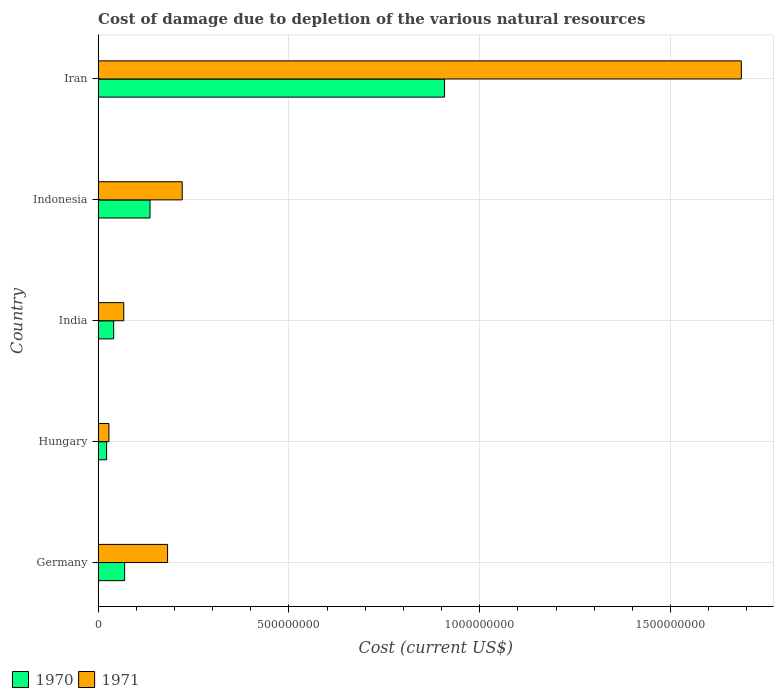Are the number of bars per tick equal to the number of legend labels?
Provide a short and direct response. Yes. Are the number of bars on each tick of the Y-axis equal?
Your answer should be very brief. Yes. How many bars are there on the 3rd tick from the bottom?
Provide a succinct answer. 2. What is the cost of damage caused due to the depletion of various natural resources in 1970 in Hungary?
Ensure brevity in your answer.  2.22e+07. Across all countries, what is the maximum cost of damage caused due to the depletion of various natural resources in 1971?
Ensure brevity in your answer.  1.69e+09. Across all countries, what is the minimum cost of damage caused due to the depletion of various natural resources in 1970?
Keep it short and to the point. 2.22e+07. In which country was the cost of damage caused due to the depletion of various natural resources in 1970 maximum?
Provide a short and direct response. Iran. In which country was the cost of damage caused due to the depletion of various natural resources in 1970 minimum?
Give a very brief answer. Hungary. What is the total cost of damage caused due to the depletion of various natural resources in 1971 in the graph?
Offer a terse response. 2.18e+09. What is the difference between the cost of damage caused due to the depletion of various natural resources in 1971 in Germany and that in Iran?
Your response must be concise. -1.50e+09. What is the difference between the cost of damage caused due to the depletion of various natural resources in 1970 in Germany and the cost of damage caused due to the depletion of various natural resources in 1971 in Hungary?
Offer a terse response. 4.12e+07. What is the average cost of damage caused due to the depletion of various natural resources in 1970 per country?
Make the answer very short. 2.35e+08. What is the difference between the cost of damage caused due to the depletion of various natural resources in 1970 and cost of damage caused due to the depletion of various natural resources in 1971 in Germany?
Offer a very short reply. -1.13e+08. In how many countries, is the cost of damage caused due to the depletion of various natural resources in 1971 greater than 1400000000 US$?
Keep it short and to the point. 1. What is the ratio of the cost of damage caused due to the depletion of various natural resources in 1970 in Germany to that in Indonesia?
Provide a short and direct response. 0.51. What is the difference between the highest and the second highest cost of damage caused due to the depletion of various natural resources in 1970?
Make the answer very short. 7.72e+08. What is the difference between the highest and the lowest cost of damage caused due to the depletion of various natural resources in 1971?
Your answer should be very brief. 1.66e+09. Is the sum of the cost of damage caused due to the depletion of various natural resources in 1970 in Germany and Hungary greater than the maximum cost of damage caused due to the depletion of various natural resources in 1971 across all countries?
Offer a very short reply. No. How many bars are there?
Offer a terse response. 10. Does the graph contain any zero values?
Make the answer very short. No. Where does the legend appear in the graph?
Ensure brevity in your answer.  Bottom left. How many legend labels are there?
Give a very brief answer. 2. What is the title of the graph?
Your answer should be very brief. Cost of damage due to depletion of the various natural resources. What is the label or title of the X-axis?
Your answer should be very brief. Cost (current US$). What is the label or title of the Y-axis?
Keep it short and to the point. Country. What is the Cost (current US$) of 1970 in Germany?
Provide a succinct answer. 6.95e+07. What is the Cost (current US$) in 1971 in Germany?
Keep it short and to the point. 1.82e+08. What is the Cost (current US$) in 1970 in Hungary?
Ensure brevity in your answer.  2.22e+07. What is the Cost (current US$) of 1971 in Hungary?
Provide a short and direct response. 2.83e+07. What is the Cost (current US$) in 1970 in India?
Make the answer very short. 4.07e+07. What is the Cost (current US$) of 1971 in India?
Provide a short and direct response. 6.72e+07. What is the Cost (current US$) in 1970 in Indonesia?
Give a very brief answer. 1.36e+08. What is the Cost (current US$) in 1971 in Indonesia?
Offer a terse response. 2.20e+08. What is the Cost (current US$) in 1970 in Iran?
Provide a short and direct response. 9.08e+08. What is the Cost (current US$) in 1971 in Iran?
Offer a very short reply. 1.69e+09. Across all countries, what is the maximum Cost (current US$) in 1970?
Your answer should be compact. 9.08e+08. Across all countries, what is the maximum Cost (current US$) in 1971?
Your answer should be compact. 1.69e+09. Across all countries, what is the minimum Cost (current US$) in 1970?
Your answer should be compact. 2.22e+07. Across all countries, what is the minimum Cost (current US$) of 1971?
Your response must be concise. 2.83e+07. What is the total Cost (current US$) in 1970 in the graph?
Your answer should be compact. 1.18e+09. What is the total Cost (current US$) of 1971 in the graph?
Your answer should be very brief. 2.18e+09. What is the difference between the Cost (current US$) of 1970 in Germany and that in Hungary?
Offer a terse response. 4.72e+07. What is the difference between the Cost (current US$) of 1971 in Germany and that in Hungary?
Your response must be concise. 1.54e+08. What is the difference between the Cost (current US$) in 1970 in Germany and that in India?
Ensure brevity in your answer.  2.88e+07. What is the difference between the Cost (current US$) in 1971 in Germany and that in India?
Provide a short and direct response. 1.15e+08. What is the difference between the Cost (current US$) in 1970 in Germany and that in Indonesia?
Your response must be concise. -6.65e+07. What is the difference between the Cost (current US$) of 1971 in Germany and that in Indonesia?
Ensure brevity in your answer.  -3.83e+07. What is the difference between the Cost (current US$) of 1970 in Germany and that in Iran?
Offer a terse response. -8.38e+08. What is the difference between the Cost (current US$) in 1971 in Germany and that in Iran?
Provide a succinct answer. -1.50e+09. What is the difference between the Cost (current US$) of 1970 in Hungary and that in India?
Ensure brevity in your answer.  -1.85e+07. What is the difference between the Cost (current US$) of 1971 in Hungary and that in India?
Provide a succinct answer. -3.89e+07. What is the difference between the Cost (current US$) in 1970 in Hungary and that in Indonesia?
Give a very brief answer. -1.14e+08. What is the difference between the Cost (current US$) of 1971 in Hungary and that in Indonesia?
Give a very brief answer. -1.92e+08. What is the difference between the Cost (current US$) of 1970 in Hungary and that in Iran?
Your response must be concise. -8.85e+08. What is the difference between the Cost (current US$) in 1971 in Hungary and that in Iran?
Make the answer very short. -1.66e+09. What is the difference between the Cost (current US$) in 1970 in India and that in Indonesia?
Your answer should be compact. -9.53e+07. What is the difference between the Cost (current US$) of 1971 in India and that in Indonesia?
Ensure brevity in your answer.  -1.53e+08. What is the difference between the Cost (current US$) of 1970 in India and that in Iran?
Your response must be concise. -8.67e+08. What is the difference between the Cost (current US$) in 1971 in India and that in Iran?
Your answer should be very brief. -1.62e+09. What is the difference between the Cost (current US$) of 1970 in Indonesia and that in Iran?
Ensure brevity in your answer.  -7.72e+08. What is the difference between the Cost (current US$) in 1971 in Indonesia and that in Iran?
Make the answer very short. -1.46e+09. What is the difference between the Cost (current US$) of 1970 in Germany and the Cost (current US$) of 1971 in Hungary?
Ensure brevity in your answer.  4.12e+07. What is the difference between the Cost (current US$) in 1970 in Germany and the Cost (current US$) in 1971 in India?
Provide a succinct answer. 2.27e+06. What is the difference between the Cost (current US$) in 1970 in Germany and the Cost (current US$) in 1971 in Indonesia?
Offer a terse response. -1.51e+08. What is the difference between the Cost (current US$) in 1970 in Germany and the Cost (current US$) in 1971 in Iran?
Offer a terse response. -1.62e+09. What is the difference between the Cost (current US$) of 1970 in Hungary and the Cost (current US$) of 1971 in India?
Your answer should be compact. -4.50e+07. What is the difference between the Cost (current US$) in 1970 in Hungary and the Cost (current US$) in 1971 in Indonesia?
Ensure brevity in your answer.  -1.98e+08. What is the difference between the Cost (current US$) in 1970 in Hungary and the Cost (current US$) in 1971 in Iran?
Offer a very short reply. -1.66e+09. What is the difference between the Cost (current US$) in 1970 in India and the Cost (current US$) in 1971 in Indonesia?
Make the answer very short. -1.80e+08. What is the difference between the Cost (current US$) of 1970 in India and the Cost (current US$) of 1971 in Iran?
Give a very brief answer. -1.64e+09. What is the difference between the Cost (current US$) of 1970 in Indonesia and the Cost (current US$) of 1971 in Iran?
Keep it short and to the point. -1.55e+09. What is the average Cost (current US$) of 1970 per country?
Make the answer very short. 2.35e+08. What is the average Cost (current US$) in 1971 per country?
Offer a very short reply. 4.37e+08. What is the difference between the Cost (current US$) in 1970 and Cost (current US$) in 1971 in Germany?
Make the answer very short. -1.13e+08. What is the difference between the Cost (current US$) in 1970 and Cost (current US$) in 1971 in Hungary?
Your answer should be very brief. -6.02e+06. What is the difference between the Cost (current US$) of 1970 and Cost (current US$) of 1971 in India?
Provide a short and direct response. -2.65e+07. What is the difference between the Cost (current US$) in 1970 and Cost (current US$) in 1971 in Indonesia?
Provide a short and direct response. -8.43e+07. What is the difference between the Cost (current US$) of 1970 and Cost (current US$) of 1971 in Iran?
Keep it short and to the point. -7.78e+08. What is the ratio of the Cost (current US$) in 1970 in Germany to that in Hungary?
Your answer should be compact. 3.12. What is the ratio of the Cost (current US$) in 1971 in Germany to that in Hungary?
Keep it short and to the point. 6.44. What is the ratio of the Cost (current US$) in 1970 in Germany to that in India?
Make the answer very short. 1.71. What is the ratio of the Cost (current US$) in 1971 in Germany to that in India?
Offer a terse response. 2.71. What is the ratio of the Cost (current US$) of 1970 in Germany to that in Indonesia?
Keep it short and to the point. 0.51. What is the ratio of the Cost (current US$) of 1971 in Germany to that in Indonesia?
Keep it short and to the point. 0.83. What is the ratio of the Cost (current US$) in 1970 in Germany to that in Iran?
Provide a short and direct response. 0.08. What is the ratio of the Cost (current US$) of 1971 in Germany to that in Iran?
Offer a very short reply. 0.11. What is the ratio of the Cost (current US$) of 1970 in Hungary to that in India?
Your response must be concise. 0.55. What is the ratio of the Cost (current US$) of 1971 in Hungary to that in India?
Offer a very short reply. 0.42. What is the ratio of the Cost (current US$) of 1970 in Hungary to that in Indonesia?
Offer a very short reply. 0.16. What is the ratio of the Cost (current US$) in 1971 in Hungary to that in Indonesia?
Give a very brief answer. 0.13. What is the ratio of the Cost (current US$) of 1970 in Hungary to that in Iran?
Ensure brevity in your answer.  0.02. What is the ratio of the Cost (current US$) in 1971 in Hungary to that in Iran?
Keep it short and to the point. 0.02. What is the ratio of the Cost (current US$) in 1970 in India to that in Indonesia?
Provide a short and direct response. 0.3. What is the ratio of the Cost (current US$) of 1971 in India to that in Indonesia?
Keep it short and to the point. 0.3. What is the ratio of the Cost (current US$) of 1970 in India to that in Iran?
Provide a short and direct response. 0.04. What is the ratio of the Cost (current US$) of 1971 in India to that in Iran?
Give a very brief answer. 0.04. What is the ratio of the Cost (current US$) of 1970 in Indonesia to that in Iran?
Your answer should be compact. 0.15. What is the ratio of the Cost (current US$) in 1971 in Indonesia to that in Iran?
Your response must be concise. 0.13. What is the difference between the highest and the second highest Cost (current US$) in 1970?
Offer a terse response. 7.72e+08. What is the difference between the highest and the second highest Cost (current US$) in 1971?
Make the answer very short. 1.46e+09. What is the difference between the highest and the lowest Cost (current US$) of 1970?
Your answer should be very brief. 8.85e+08. What is the difference between the highest and the lowest Cost (current US$) of 1971?
Provide a succinct answer. 1.66e+09. 